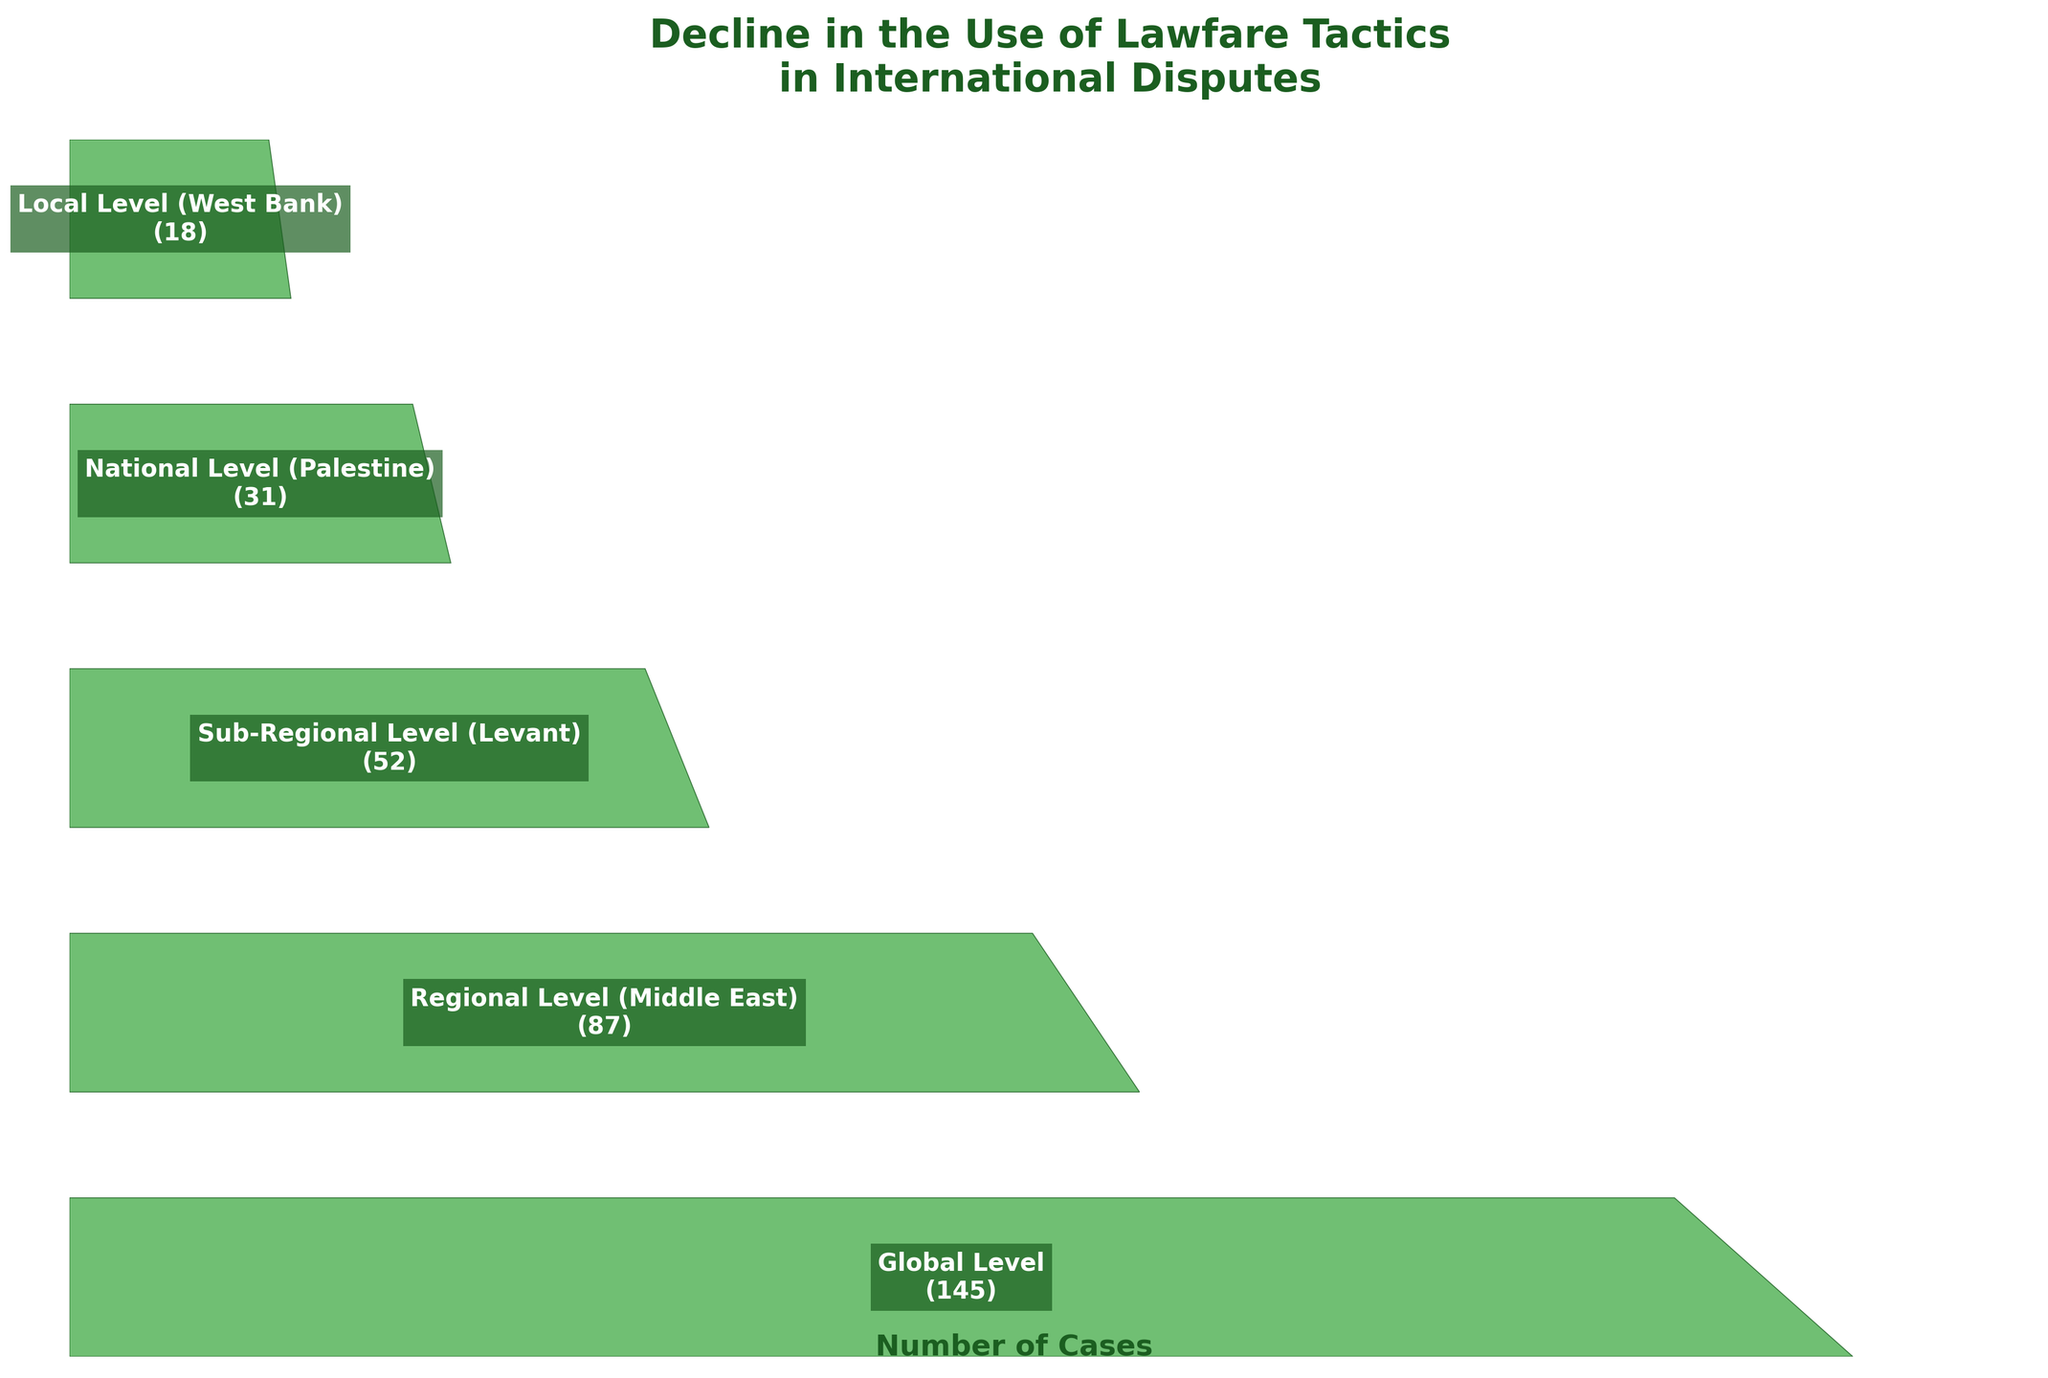How many stages are shown in the funnel chart? The funnel chart lists different stages based on geographical region. To find the number of stages, count the different levels mentioned in the chart. The levels are: Global Level, Regional Level (Middle East), Sub-Regional Level (Levant), National Level (Palestine), and Local Level (West Bank). There are 5 stages in total.
Answer: 5 What is the decrease in the number of cases from the Global Level to the Local Level? To find the decrease, subtract the number of cases at the Local Level from the number of cases at the Global Level. The Global Level has 145 cases, and the Local Level has 18 cases. The decrease is 145 - 18 = 127 cases.
Answer: 127 Which stage has the least number of cases? To find this, examine the number of cases for each stage. The stages are: Global Level (145 cases), Regional Level (87 cases), Sub-Regional Level (52 cases), National Level (31 cases), Local Level (18 cases). The Local Level (West Bank) has the least number of cases.
Answer: Local Level (West Bank) Is the number of cases at the Sub-Regional Level more or less than half of the Global Level? To determine this, first find half of the Global Level cases: 145 / 2 = 72.5 cases. Then compare it to the number of cases at the Sub-Regional Level, which is 52. Since 52 is less than 72.5, the number of cases at the Sub-Regional Level is less than half of the Global Level.
Answer: Less What is the average number of cases from the Regional Level to the Local Level? To find the average, sum the number of cases at the Regional Level, Sub-Regional Level, National Level, and Local Level, then divide by four. The sums of the cases are 87 + 52 + 31 + 18 = 188. Since there are 4 stages, the average is 188 / 4 = 47 cases.
Answer: 47 By how many cases does the number of cases change between each consecutive stage? Calculate the difference between consecutive stages. For Global to Regional: 145 - 87 = 58. For Regional to Sub-Regional: 87 - 52 = 35. For Sub-Regional to National: 52 - 31 = 21. For National to Local: 31 - 18 = 13. Therefore, the changes are 58, 35, 21, and 13 cases respectively.
Answer: 58, 35, 21, 13 What is the specific percentage decrease from National Level to Local Level? To find the percentage decrease, use the formula [(Initial - Final) / Initial] * 100. Here, Initial = 31 (National Level cases), and Final = 18 (Local Level cases). So the percentage decrease is [(31 - 18) / 31] * 100 = (13 / 31) * 100 ≈ 41.94%.
Answer: 41.94% What is the title of the funnel chart? The title of the funnel chart is written above the chart in a larger, bold font. It reads: "Decline in the Use of Lawfare Tactics in International Disputes."
Answer: Decline in the Use of Lawfare Tactics in International Disputes Which stage shows a similar number of cases to the National Level? To find this, compare the National Level cases (31) with other stages. Regional Level (87), Sub-Regional Level (52), and Local Level (18) are quite different from 31. There is no other stage that shows a similar number of cases to the National Level (31).
Answer: None Between which levels does the steepest drop in the number of cases occur? The steepest drop can be identified by finding the largest difference between consecutive stages. Compare the differences: 58 (Global to Regional), 35 (Regional to Sub-Regional), 21 (Sub-Regional to National), and 13 (National to Local). The largest drop is between Global and Regional Levels (58 cases).
Answer: Between Global Level and Regional Level 